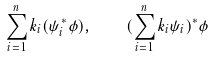<formula> <loc_0><loc_0><loc_500><loc_500>\sum _ { i = 1 } ^ { n } k _ { i } ( \psi _ { i } ^ { * } \phi ) , \quad ( \sum _ { i = 1 } ^ { n } k _ { i } \psi _ { i } ) ^ { * } \phi</formula> 